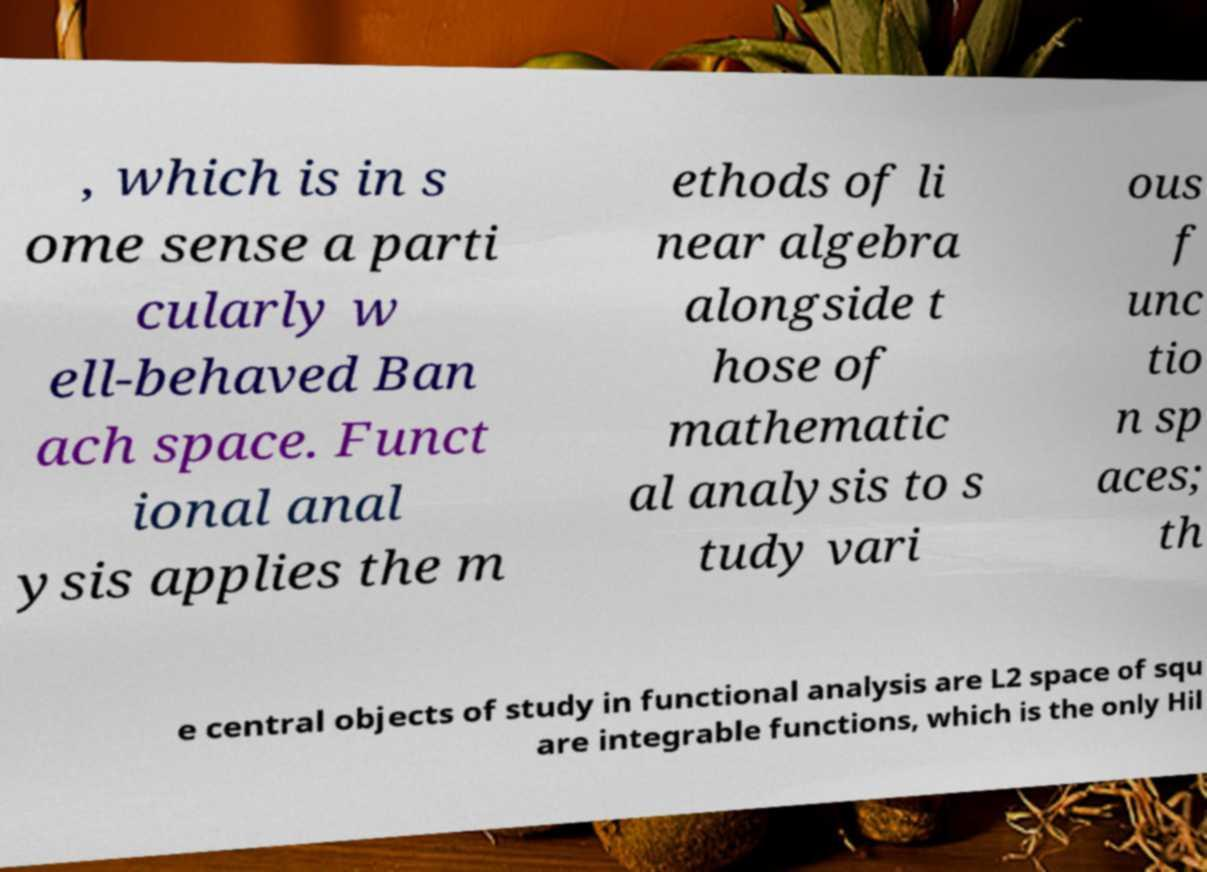Could you assist in decoding the text presented in this image and type it out clearly? , which is in s ome sense a parti cularly w ell-behaved Ban ach space. Funct ional anal ysis applies the m ethods of li near algebra alongside t hose of mathematic al analysis to s tudy vari ous f unc tio n sp aces; th e central objects of study in functional analysis are L2 space of squ are integrable functions, which is the only Hil 